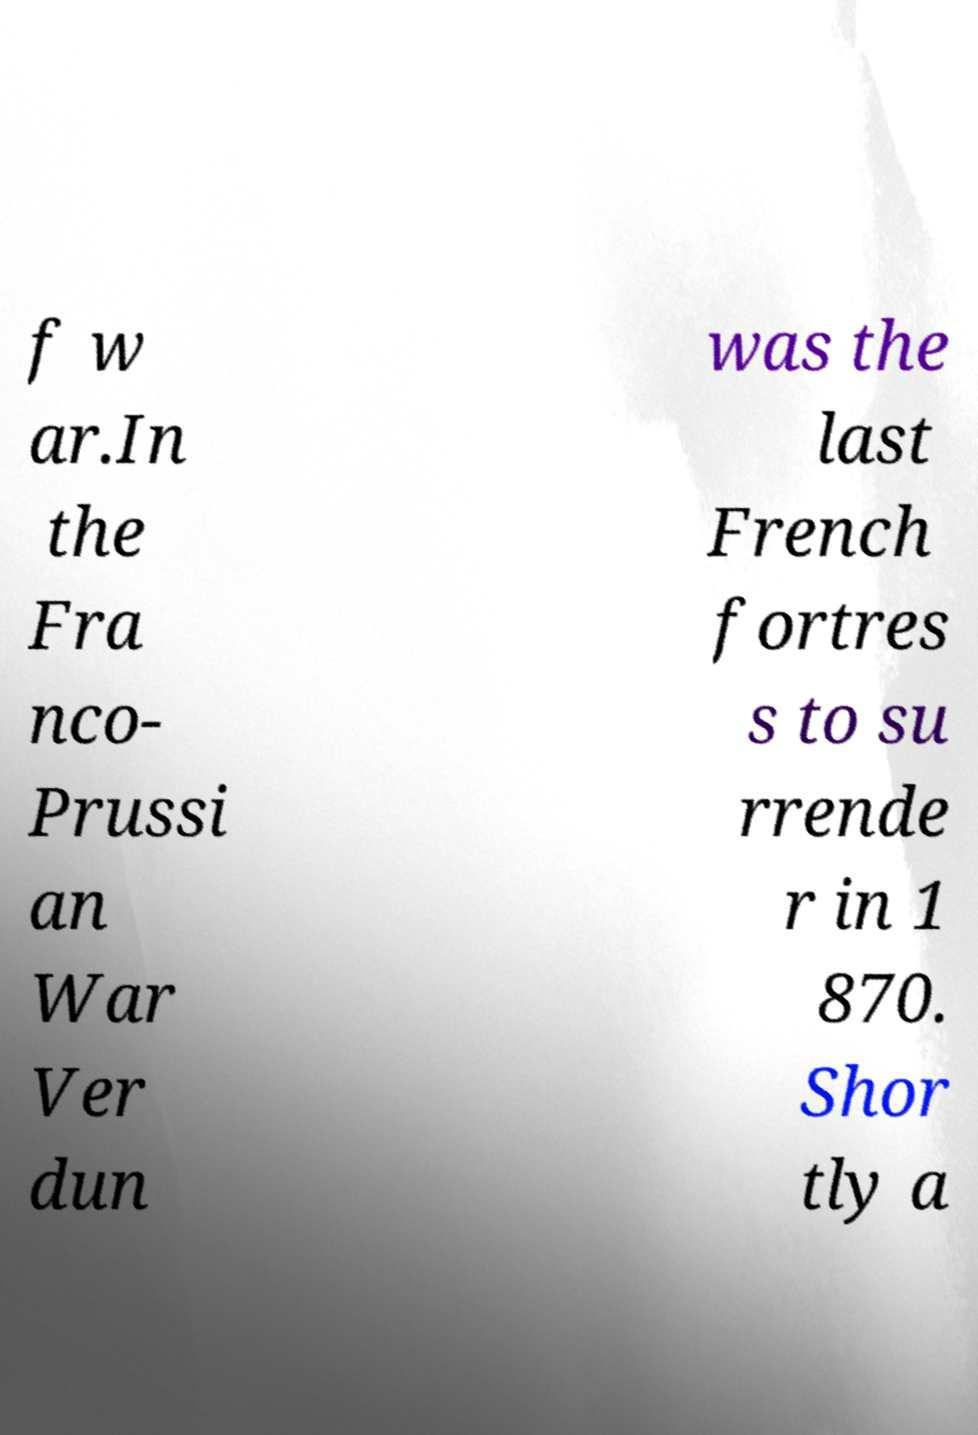Can you read and provide the text displayed in the image?This photo seems to have some interesting text. Can you extract and type it out for me? f w ar.In the Fra nco- Prussi an War Ver dun was the last French fortres s to su rrende r in 1 870. Shor tly a 